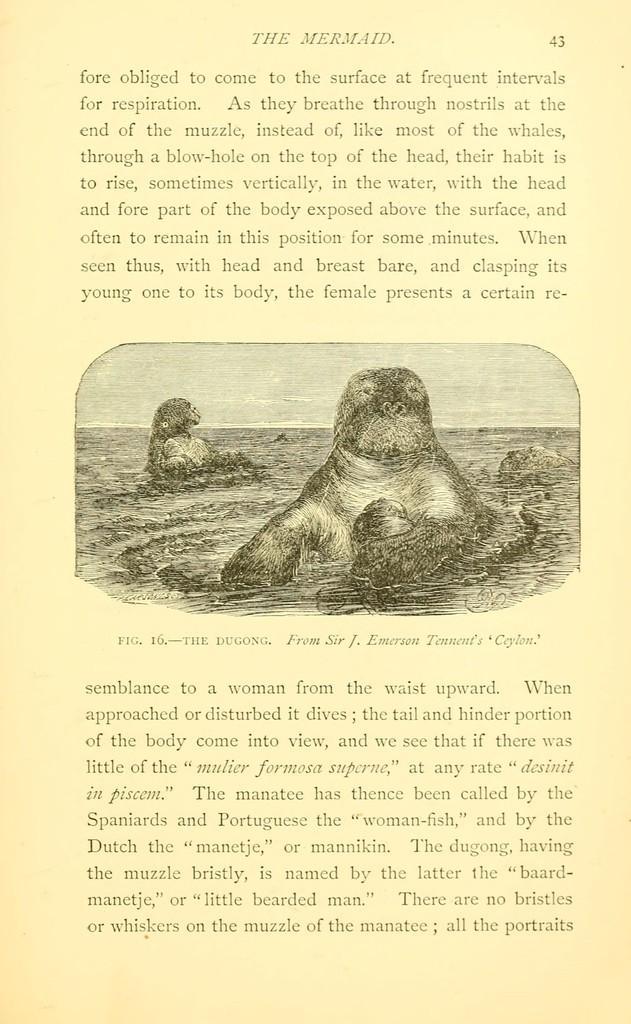How would you summarize this image in a sentence or two? In the foreground of this poster, there is some text and an image, where we can see two animals in the water. 